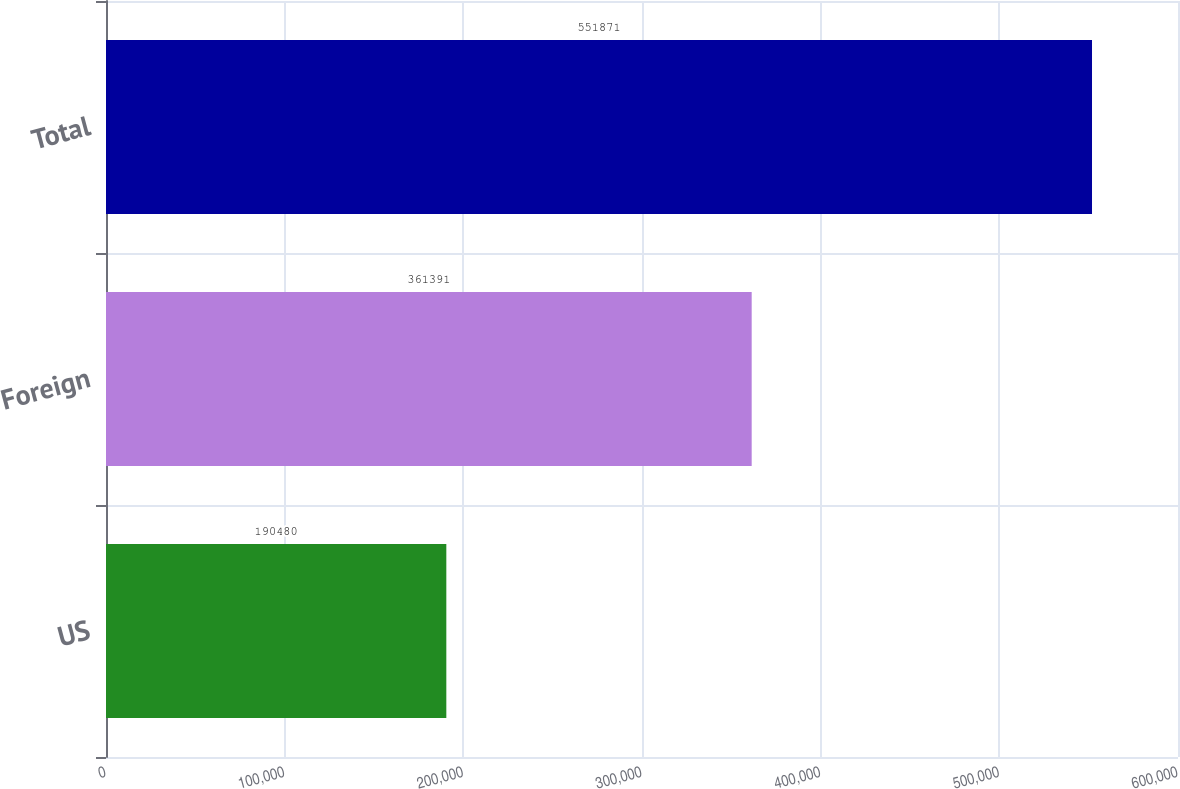Convert chart to OTSL. <chart><loc_0><loc_0><loc_500><loc_500><bar_chart><fcel>US<fcel>Foreign<fcel>Total<nl><fcel>190480<fcel>361391<fcel>551871<nl></chart> 